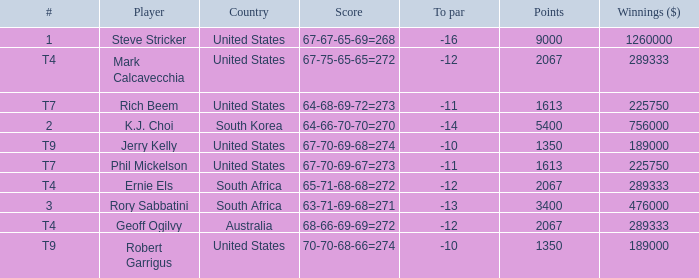Name the number of points for south korea 1.0. 